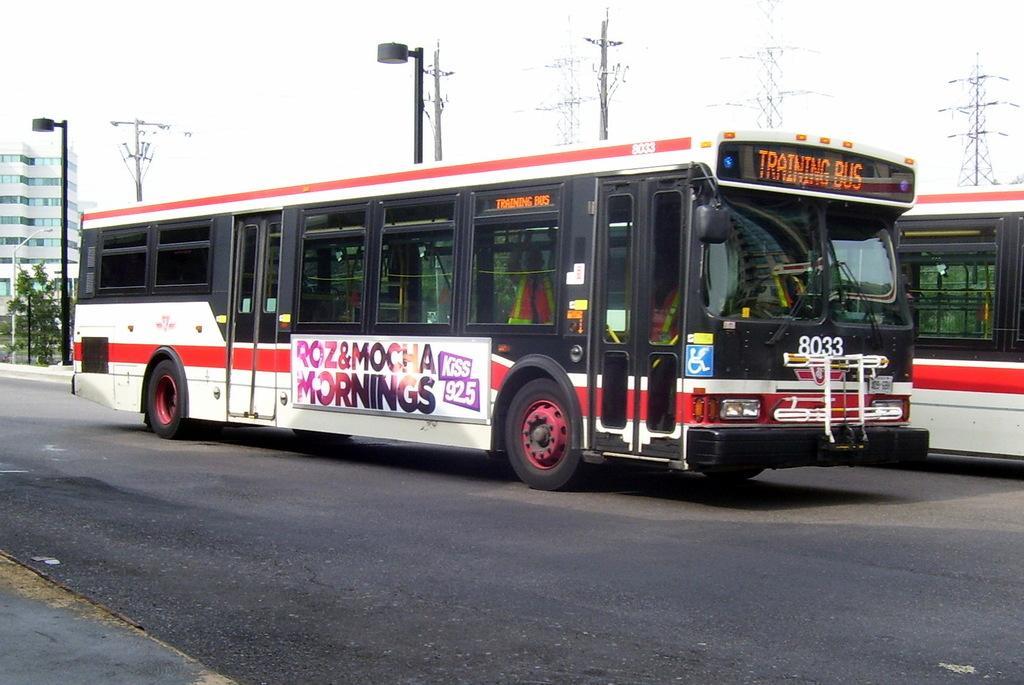Describe this image in one or two sentences. In this image I see the road on which there are 2 buses which are of white and red in color and I see something is written on this bus and I see the windows and in the background I see the poles, few trees and I see the building over here and I see the sky. 